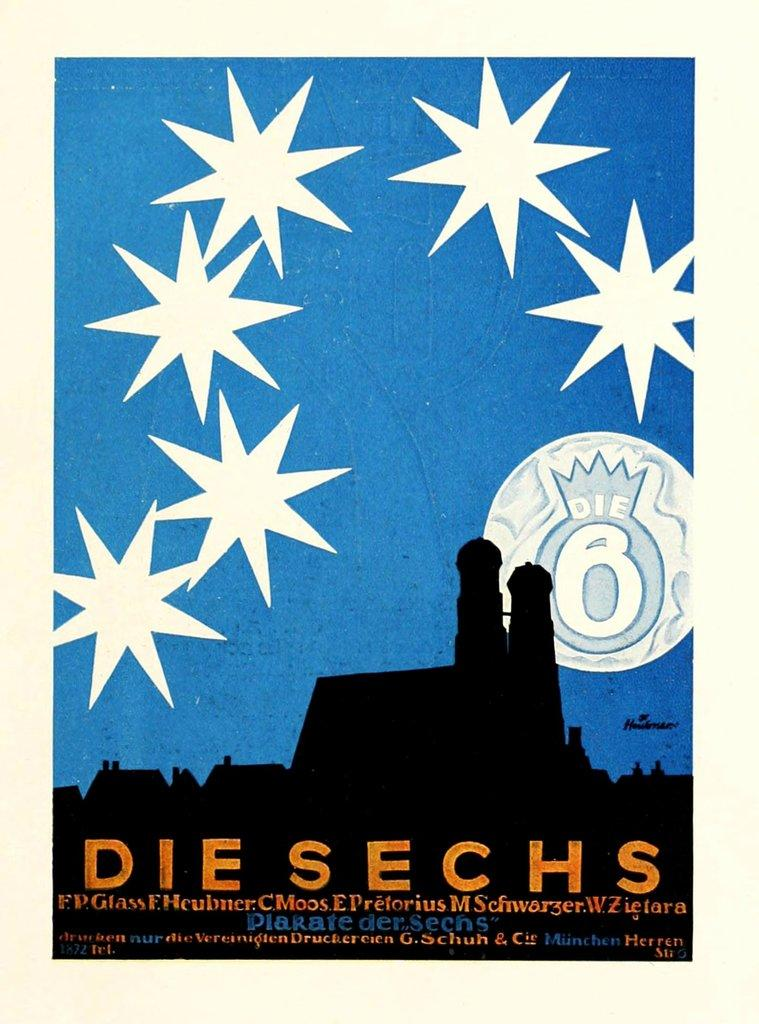<image>
Offer a succinct explanation of the picture presented. a post for die sechs with stars on it 